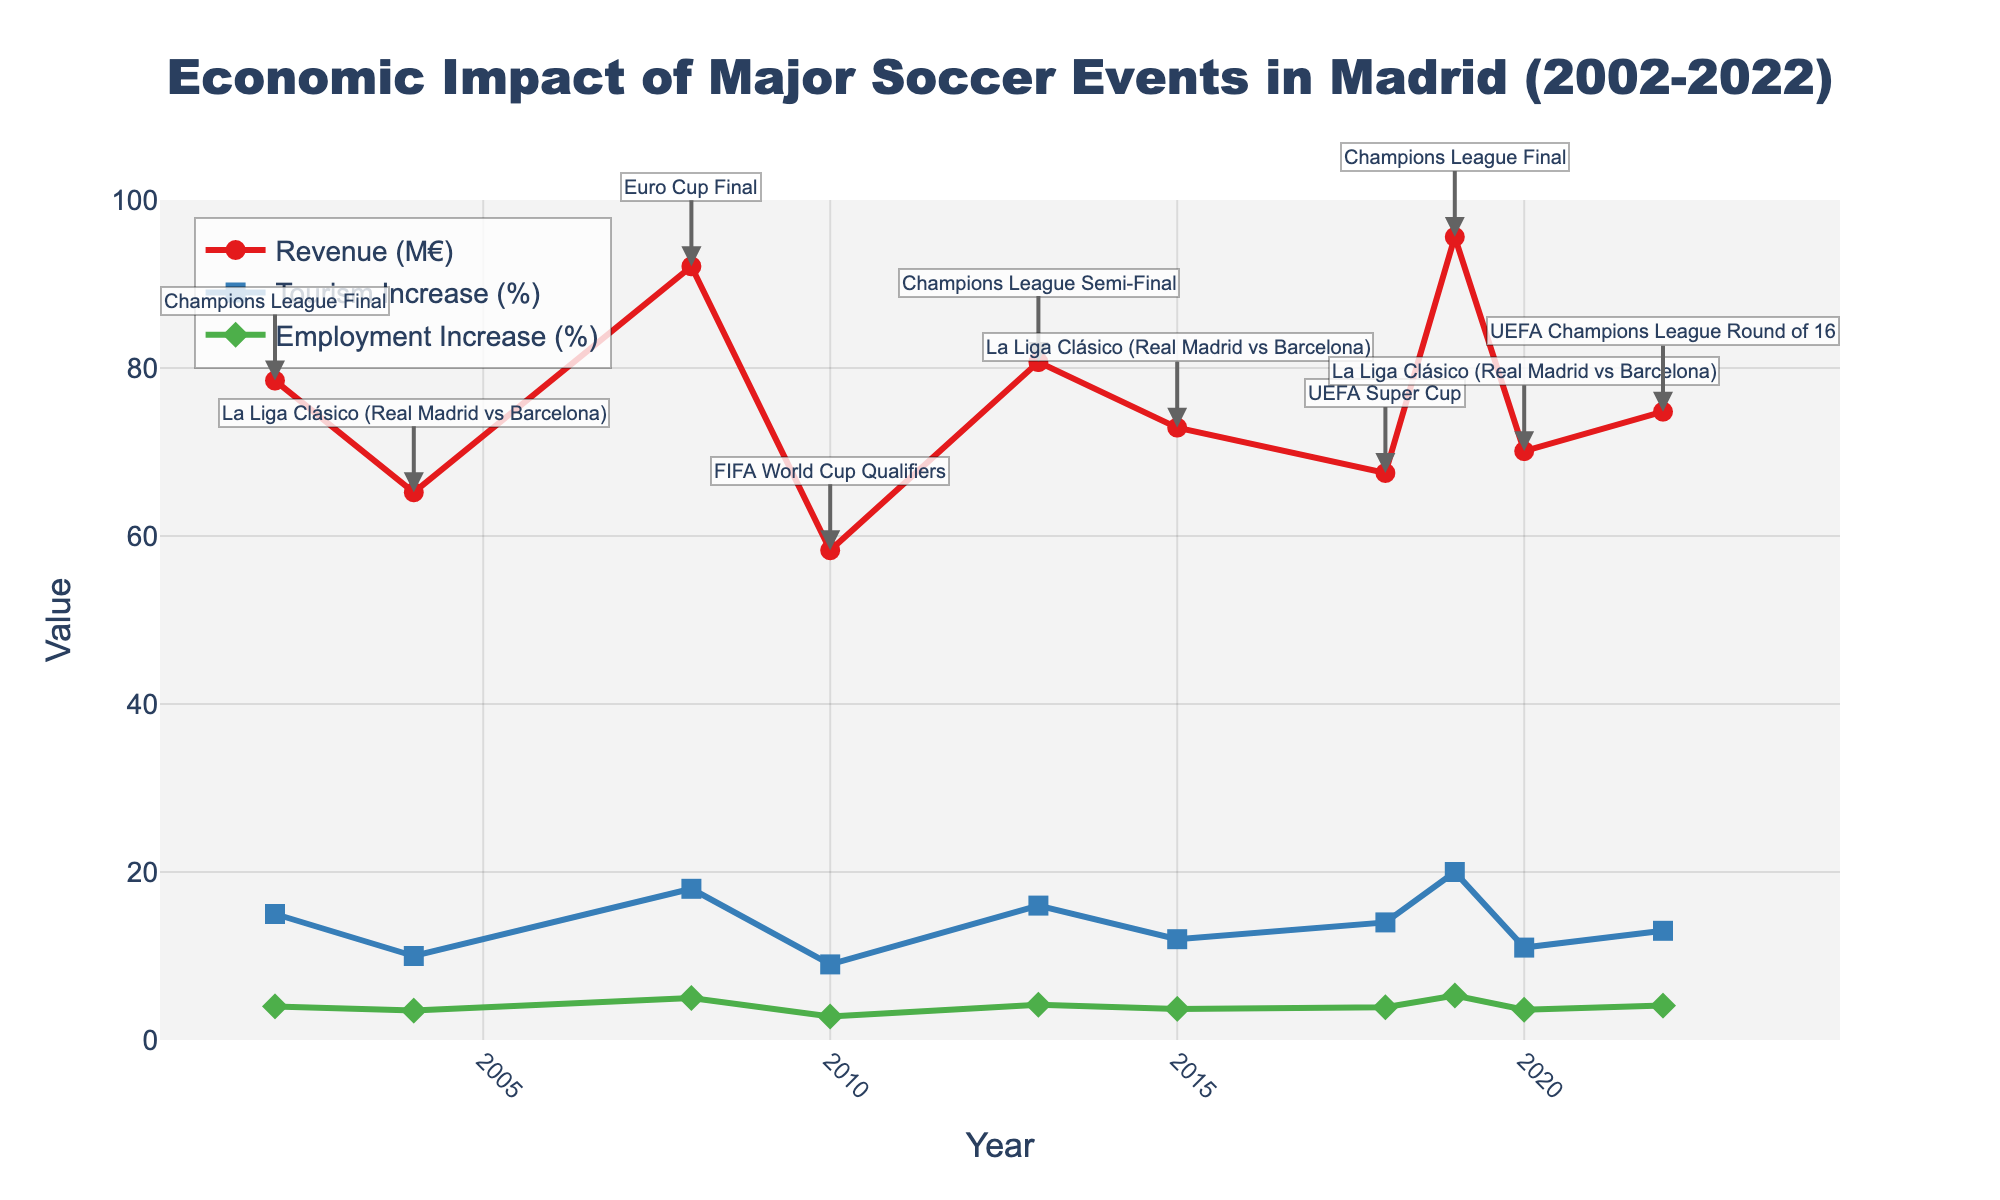What is the title of the figure? The title of the figure is displayed at the top and it summarizes the content of the plot. It reads, "Economic Impact of Major Soccer Events in Madrid (2002-2022)."
Answer: Economic Impact of Major Soccer Events in Madrid (2002-2022) How many major soccer events are plotted in the figure? By counting the number of annotations or markers on the figure, we can see that there are 10 major soccer events plotted.
Answer: 10 Which year had the highest revenue generated, and what was the revenue? By looking at the line representing revenue, the peak can be identified. The highest point occurs in 2019, with the annotation indicating it was 95.6 million Euros.
Answer: 2019, 95.6 million Euros Did tourism increase more in 2015 or 2018? By comparing the tourism increase percentages for 2015 and 2018, we see that 2015 had a 12% increase while 2018 had a 14% increase.
Answer: 2018 What is the general trend in employment increase (%) over the years? By observing the line representing employment increase, it is evident that there is a generally rising trend, with some fluctuations. The increase is gradual over the years.
Answer: Gradually rising Which two events generated the highest revenue in the plot? By looking at the peaks in the revenue line, we can identify the two highest points. These are the 2019 Champions League Final (95.6 million Euros) and the 2008 Euro Cup Final (92.1 million Euros).
Answer: Champions League Final 2019, Euro Cup Final 2008 Which year showed both the highest tourism increase and the highest employment increase? Checking the peaks in both the tourism and employment lines, we find that 2019 has the highest values for both metrics, with 20% tourism increase and 5.3% employment increase.
Answer: 2019 What is the average revenue generated by the Champions League Final events across the years? The Champions League Final events occurred in 2002, 2013, and 2019 with revenues of 78.5, 80.7, and 95.6 million Euros respectively. The average is calculated as (78.5 + 80.7 + 95.6) / 3 = 84.93 million Euros.
Answer: 84.93 million Euros How does the revenue in 2022 compare to that in 2002? The revenue in 2002 was 78.5 million Euros, and in 2022, it was 74.8 million Euros. 2022's revenue is slightly lower than that of 2002.
Answer: Lower 